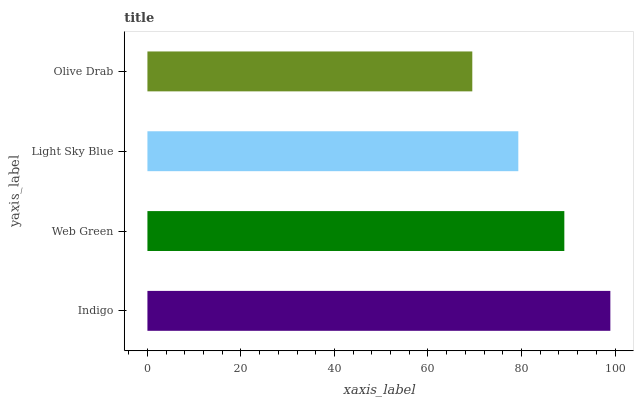Is Olive Drab the minimum?
Answer yes or no. Yes. Is Indigo the maximum?
Answer yes or no. Yes. Is Web Green the minimum?
Answer yes or no. No. Is Web Green the maximum?
Answer yes or no. No. Is Indigo greater than Web Green?
Answer yes or no. Yes. Is Web Green less than Indigo?
Answer yes or no. Yes. Is Web Green greater than Indigo?
Answer yes or no. No. Is Indigo less than Web Green?
Answer yes or no. No. Is Web Green the high median?
Answer yes or no. Yes. Is Light Sky Blue the low median?
Answer yes or no. Yes. Is Indigo the high median?
Answer yes or no. No. Is Olive Drab the low median?
Answer yes or no. No. 